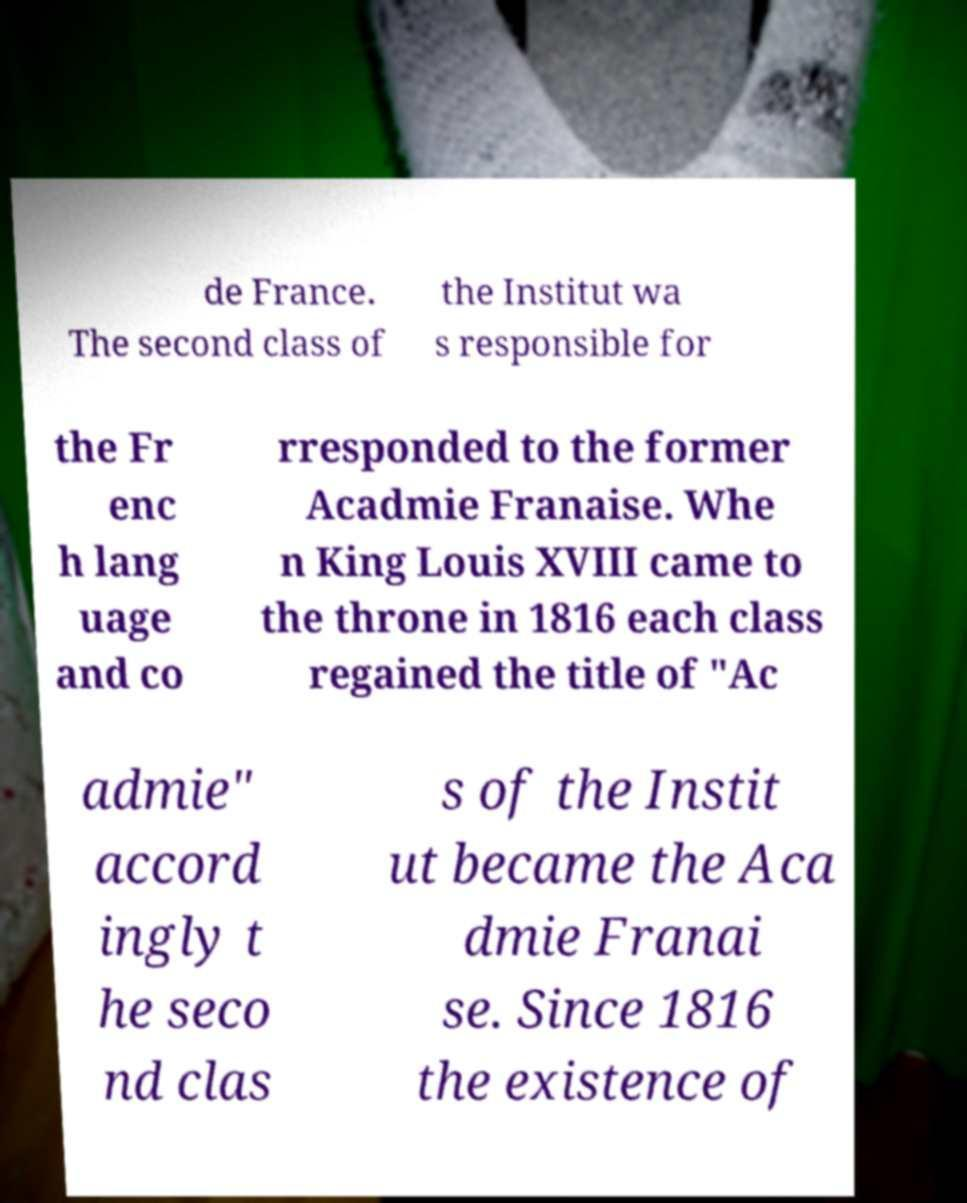Can you read and provide the text displayed in the image?This photo seems to have some interesting text. Can you extract and type it out for me? de France. The second class of the Institut wa s responsible for the Fr enc h lang uage and co rresponded to the former Acadmie Franaise. Whe n King Louis XVIII came to the throne in 1816 each class regained the title of "Ac admie" accord ingly t he seco nd clas s of the Instit ut became the Aca dmie Franai se. Since 1816 the existence of 